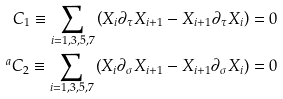<formula> <loc_0><loc_0><loc_500><loc_500>C _ { 1 } \equiv \sum _ { i = 1 , 3 , 5 , 7 } \left ( X _ { i } \partial _ { \tau } X _ { i + 1 } - X _ { i + 1 } \partial _ { \tau } X _ { i } \right ) = 0 \\ ^ { a } C _ { 2 } \equiv \sum _ { i = 1 , 3 , 5 , 7 } \left ( X _ { i } \partial _ { \sigma } X _ { i + 1 } - X _ { i + 1 } \partial _ { \sigma } X _ { i } \right ) = 0</formula> 